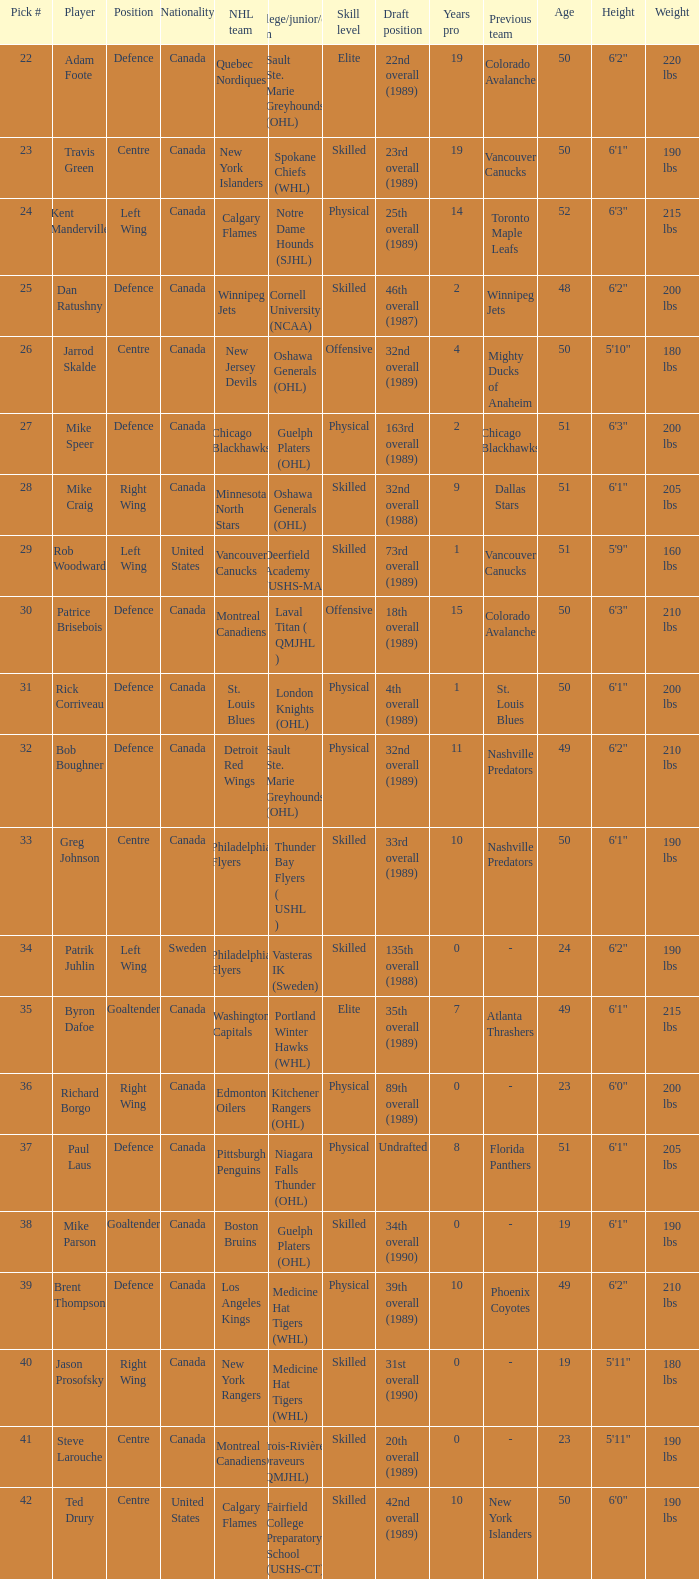Who is the player that emerged from cornell university (ncaa)? Dan Ratushny. 